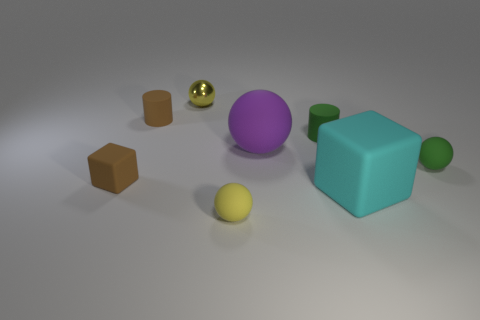There is a sphere in front of the brown block; is it the same color as the tiny ball that is behind the purple rubber sphere?
Offer a very short reply. Yes. Is there anything else of the same color as the metallic sphere?
Your answer should be compact. Yes. There is a matte thing that is left of the cylinder to the left of the shiny ball; is there a small rubber object that is behind it?
Provide a short and direct response. Yes. There is a tiny matte sphere that is left of the large sphere; is it the same color as the shiny sphere?
Your answer should be very brief. Yes. How many spheres are yellow rubber objects or small objects?
Provide a succinct answer. 3. There is a small thing in front of the tiny brown matte object in front of the big purple rubber ball; what is its shape?
Your answer should be compact. Sphere. How big is the rubber cube that is on the right side of the yellow object that is behind the small yellow ball in front of the small brown matte cube?
Offer a terse response. Large. Does the brown matte cylinder have the same size as the green ball?
Your response must be concise. Yes. What number of objects are either big cyan blocks or big cyan metallic cubes?
Ensure brevity in your answer.  1. There is a block to the right of the rubber cylinder that is right of the small yellow rubber ball; how big is it?
Your response must be concise. Large. 